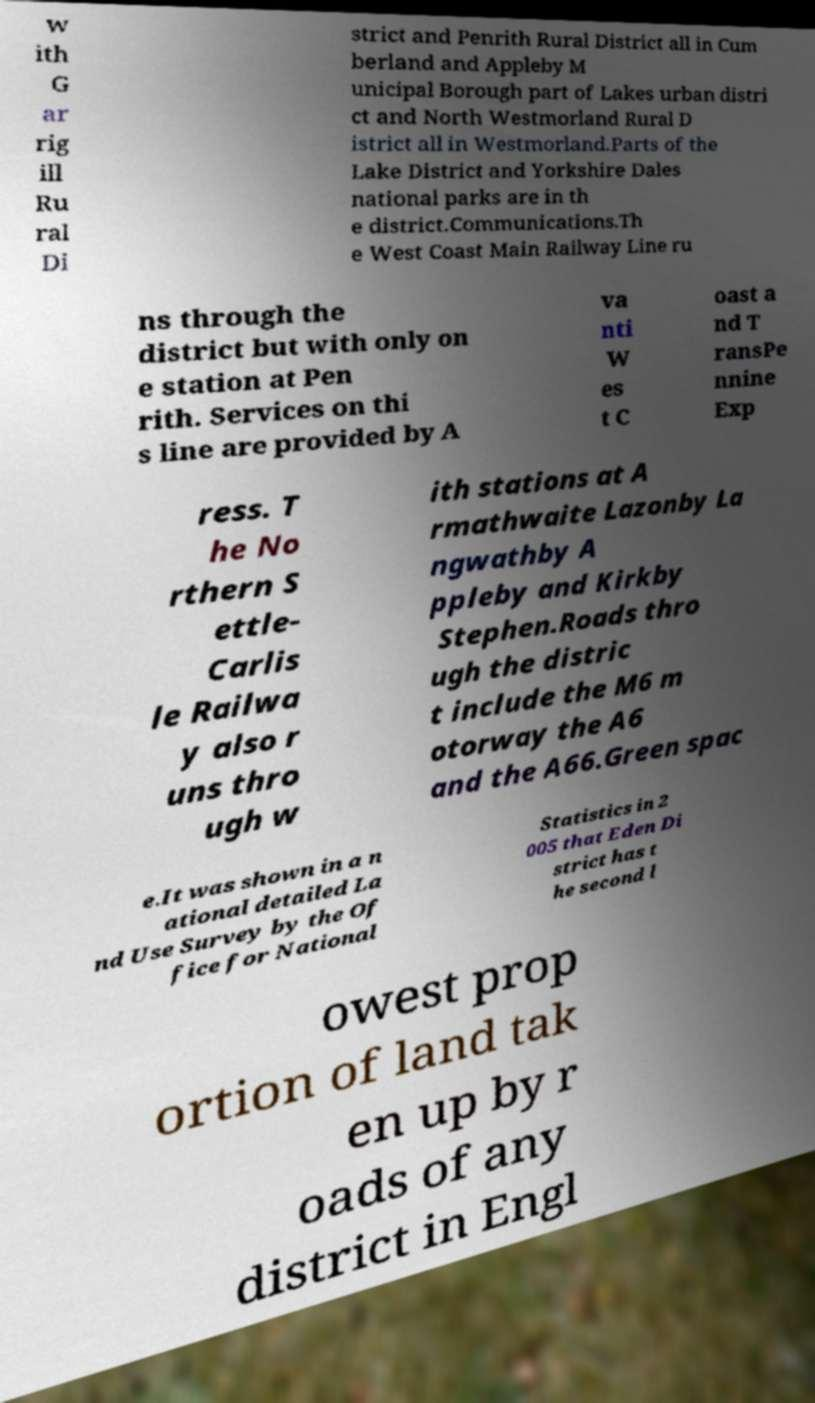What messages or text are displayed in this image? I need them in a readable, typed format. w ith G ar rig ill Ru ral Di strict and Penrith Rural District all in Cum berland and Appleby M unicipal Borough part of Lakes urban distri ct and North Westmorland Rural D istrict all in Westmorland.Parts of the Lake District and Yorkshire Dales national parks are in th e district.Communications.Th e West Coast Main Railway Line ru ns through the district but with only on e station at Pen rith. Services on thi s line are provided by A va nti W es t C oast a nd T ransPe nnine Exp ress. T he No rthern S ettle- Carlis le Railwa y also r uns thro ugh w ith stations at A rmathwaite Lazonby La ngwathby A ppleby and Kirkby Stephen.Roads thro ugh the distric t include the M6 m otorway the A6 and the A66.Green spac e.It was shown in a n ational detailed La nd Use Survey by the Of fice for National Statistics in 2 005 that Eden Di strict has t he second l owest prop ortion of land tak en up by r oads of any district in Engl 